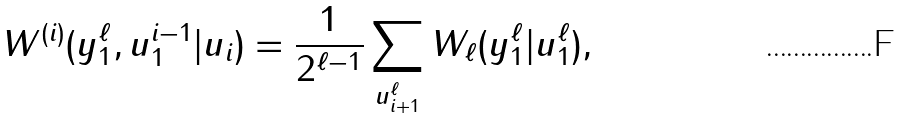Convert formula to latex. <formula><loc_0><loc_0><loc_500><loc_500>W ^ { ( i ) } ( y _ { 1 } ^ { \ell } , u _ { 1 } ^ { i - 1 } | u _ { i } ) = \frac { 1 } { 2 ^ { \ell - 1 } } \sum _ { u _ { i + 1 } ^ { \ell } } W _ { \ell } ( y _ { 1 } ^ { \ell } | u _ { 1 } ^ { \ell } ) ,</formula> 